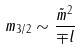<formula> <loc_0><loc_0><loc_500><loc_500>m _ { 3 / 2 } \sim \frac { \tilde { m } ^ { 2 } } { \mp l }</formula> 